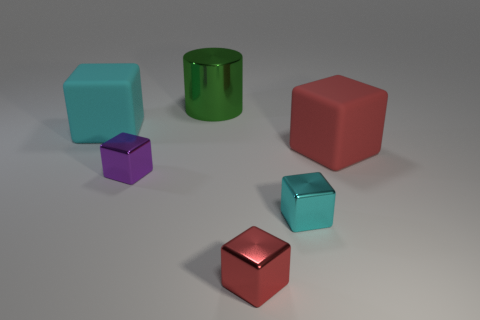The big matte object that is to the right of the red block that is in front of the matte thing in front of the big cyan rubber object is what color?
Offer a terse response. Red. Is the material of the big thing right of the big green object the same as the cyan cube on the left side of the red shiny thing?
Make the answer very short. Yes. What number of things are purple metal cubes that are in front of the cyan rubber cube or cyan rubber objects?
Provide a short and direct response. 2. What number of objects are large rubber cubes or rubber objects that are on the left side of the big red cube?
Ensure brevity in your answer.  2. What number of objects are the same size as the red matte cube?
Your answer should be compact. 2. Are there fewer big red rubber things that are in front of the cyan metal object than tiny cyan things behind the large green shiny cylinder?
Your answer should be compact. No. How many shiny objects are tiny red things or brown spheres?
Ensure brevity in your answer.  1. The green thing is what shape?
Offer a very short reply. Cylinder. What material is the cyan object that is the same size as the red rubber block?
Give a very brief answer. Rubber. How many large things are either red things or cubes?
Offer a very short reply. 2. 